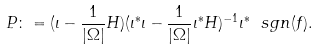Convert formula to latex. <formula><loc_0><loc_0><loc_500><loc_500>P \colon = ( \iota - \frac { 1 } { | \Omega | } H ) ( \iota ^ { * } \iota - \frac { 1 } { | \Omega | } \iota ^ { * } H ) ^ { - 1 } \iota ^ { * } \ s g n ( f ) .</formula> 